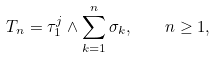Convert formula to latex. <formula><loc_0><loc_0><loc_500><loc_500>T _ { n } = \tau _ { 1 } ^ { j } \wedge \sum _ { k = 1 } ^ { n } \sigma _ { k } , \quad n \geq 1 ,</formula> 